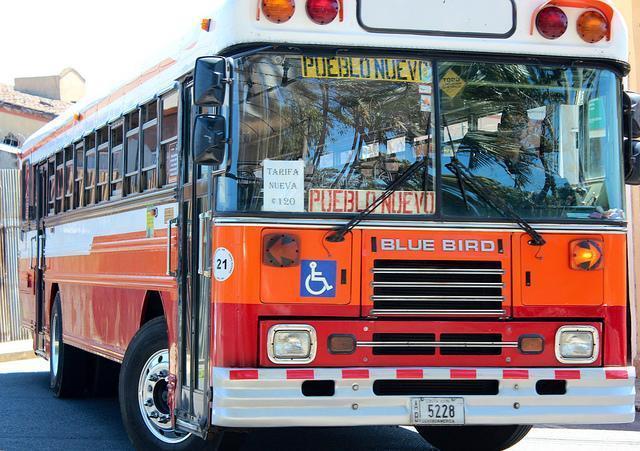How many people are there?
Give a very brief answer. 1. 